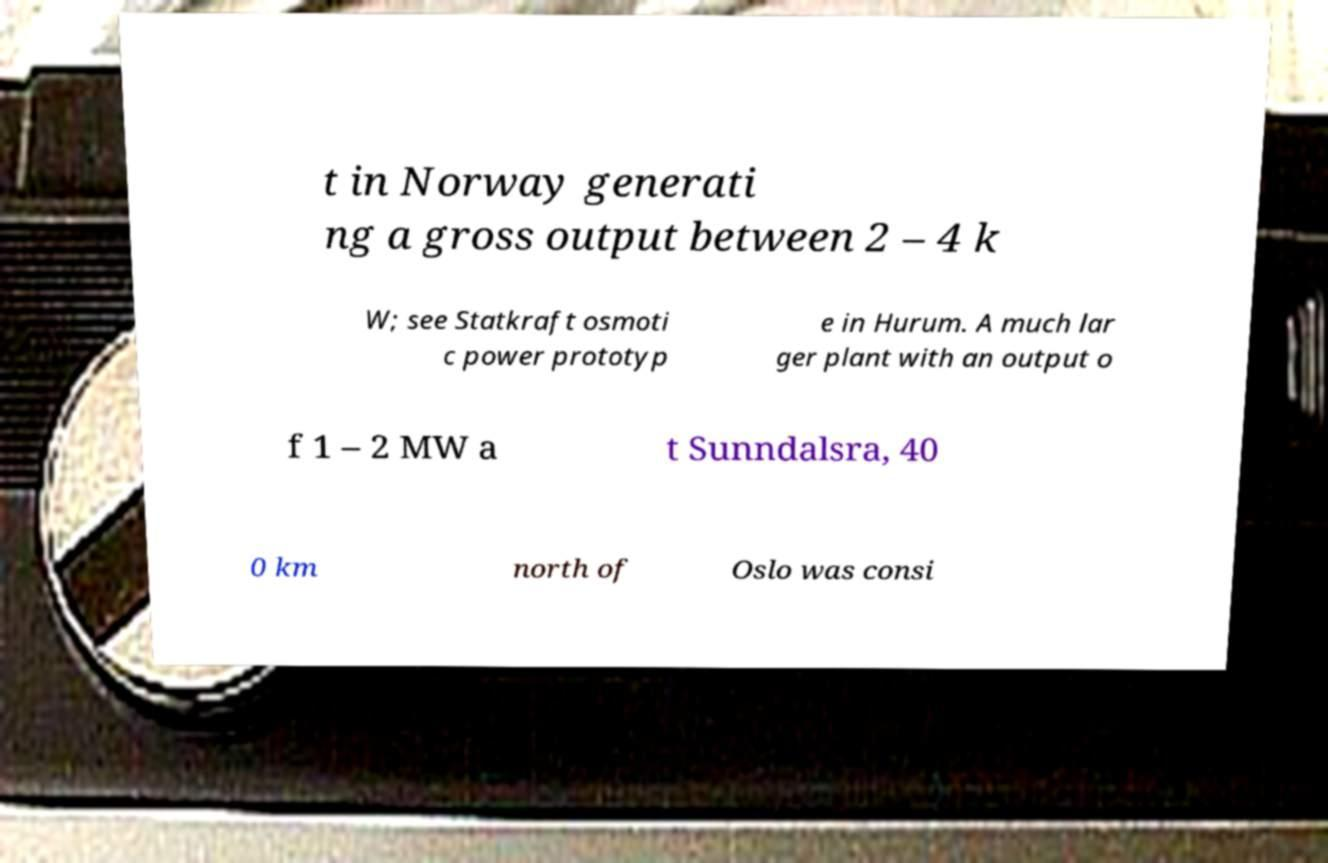For documentation purposes, I need the text within this image transcribed. Could you provide that? t in Norway generati ng a gross output between 2 – 4 k W; see Statkraft osmoti c power prototyp e in Hurum. A much lar ger plant with an output o f 1 – 2 MW a t Sunndalsra, 40 0 km north of Oslo was consi 